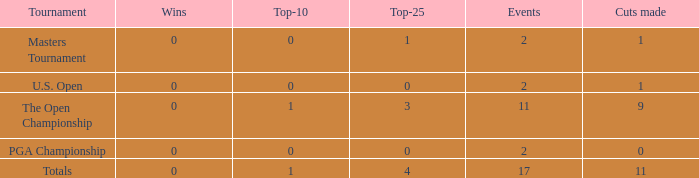What is his highest number of top 25s when eh played over 2 events and under 0 wins? None. 